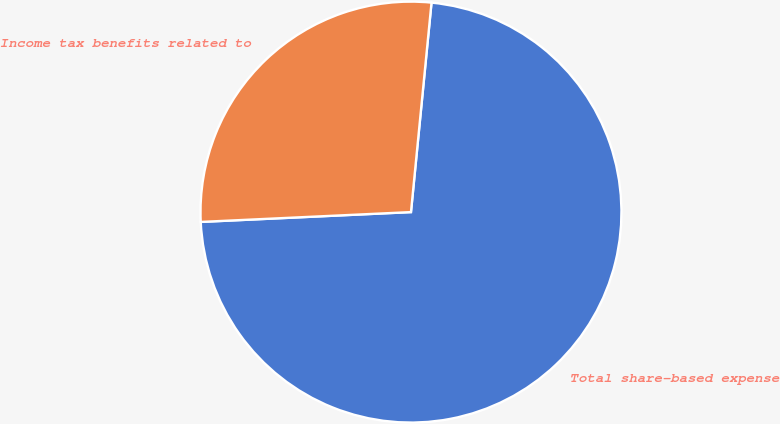<chart> <loc_0><loc_0><loc_500><loc_500><pie_chart><fcel>Total share-based expense<fcel>Income tax benefits related to<nl><fcel>72.7%<fcel>27.3%<nl></chart> 